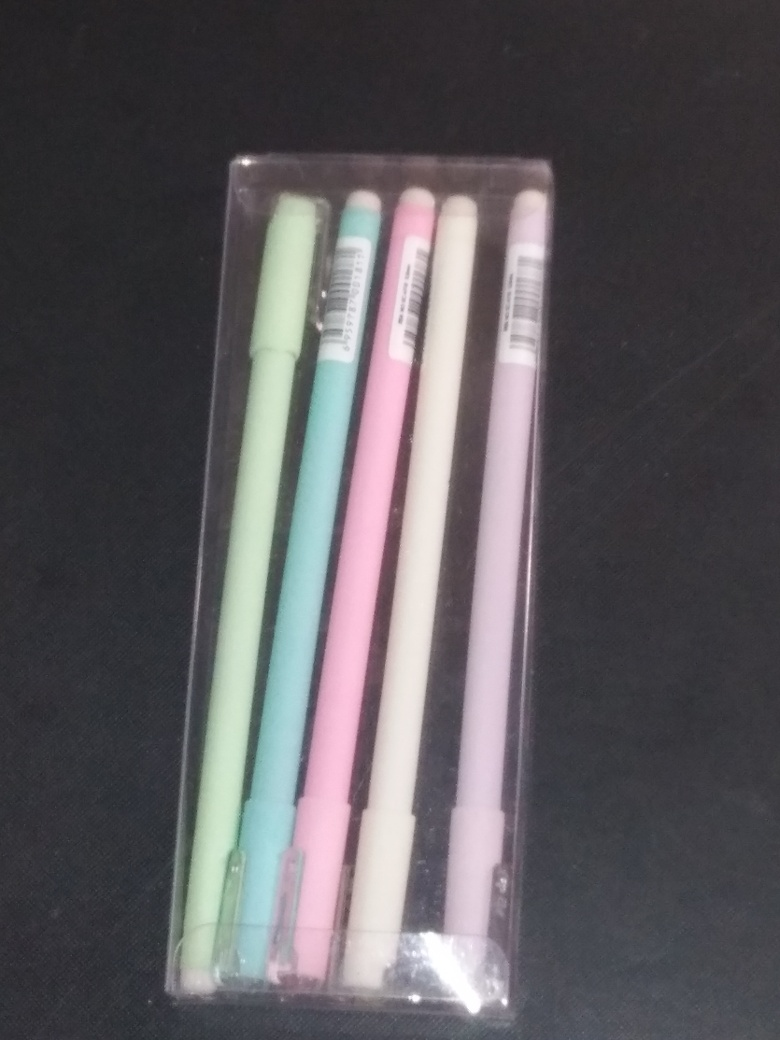It's hard to tell, but can you describe the setting or context where this image might have been taken? Sure, the image has a simplistic setup with a focus on the item itself, suggesting it might have been taken indoors, likely on a plain surface with no distinct background features. The lighting is a bit dim but sufficient, implying it may have been taken in a home or office environment, possibly for the purpose of selling the pens or simply documenting them. 